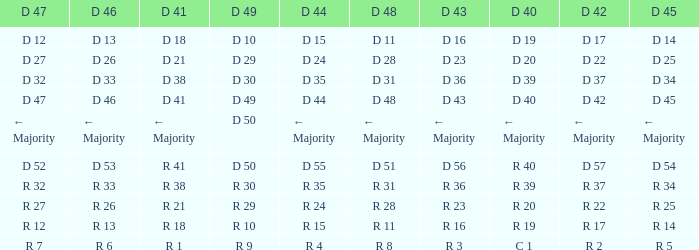I want the D 40 with D 44 of d 15 D 19. 